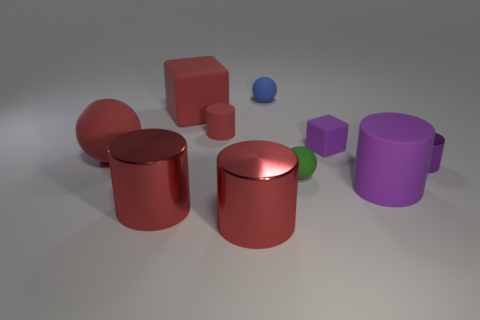Subtract all green spheres. How many red cylinders are left? 3 Subtract 2 cylinders. How many cylinders are left? 3 Subtract all small rubber cylinders. How many cylinders are left? 4 Subtract all yellow cubes. Subtract all gray spheres. How many cubes are left? 2 Subtract all spheres. How many objects are left? 7 Subtract 0 blue cylinders. How many objects are left? 10 Subtract all cylinders. Subtract all matte cylinders. How many objects are left? 3 Add 6 tiny purple blocks. How many tiny purple blocks are left? 7 Add 9 red blocks. How many red blocks exist? 10 